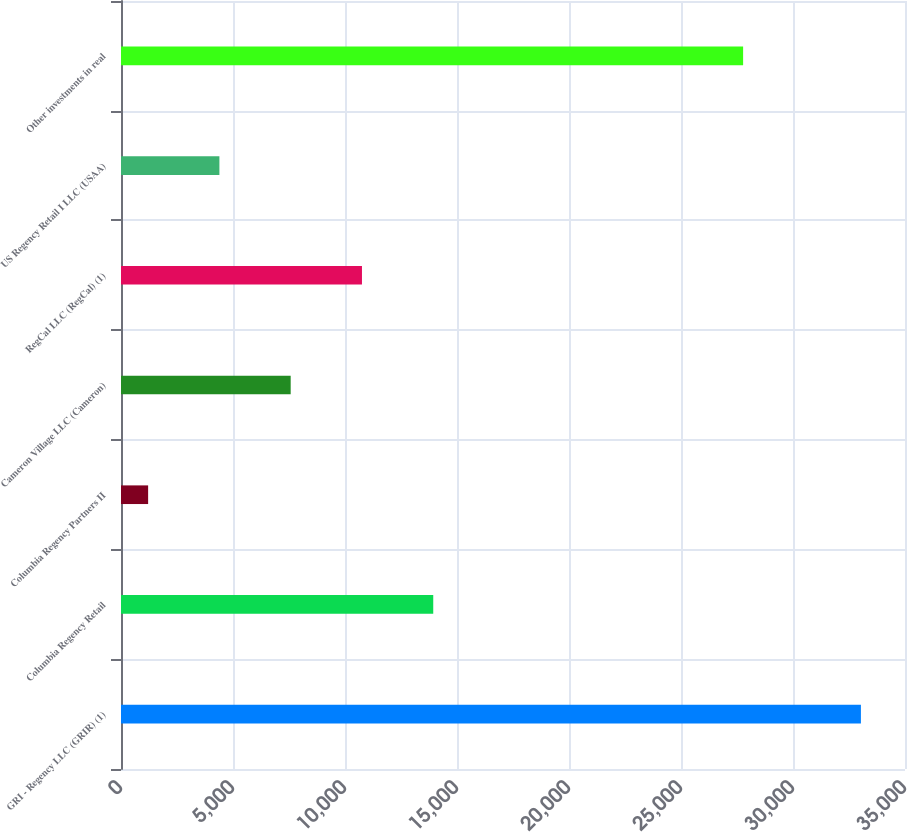Convert chart. <chart><loc_0><loc_0><loc_500><loc_500><bar_chart><fcel>GRI - Regency LLC (GRIR) (1)<fcel>Columbia Regency Retail<fcel>Columbia Regency Partners II<fcel>Cameron Village LLC (Cameron)<fcel>RegCal LLC (RegCal) (1)<fcel>US Regency Retail I LLC (USAA)<fcel>Other investments in real<nl><fcel>33032<fcel>13939.4<fcel>1211<fcel>7575.2<fcel>10757.3<fcel>4393.1<fcel>27773<nl></chart> 